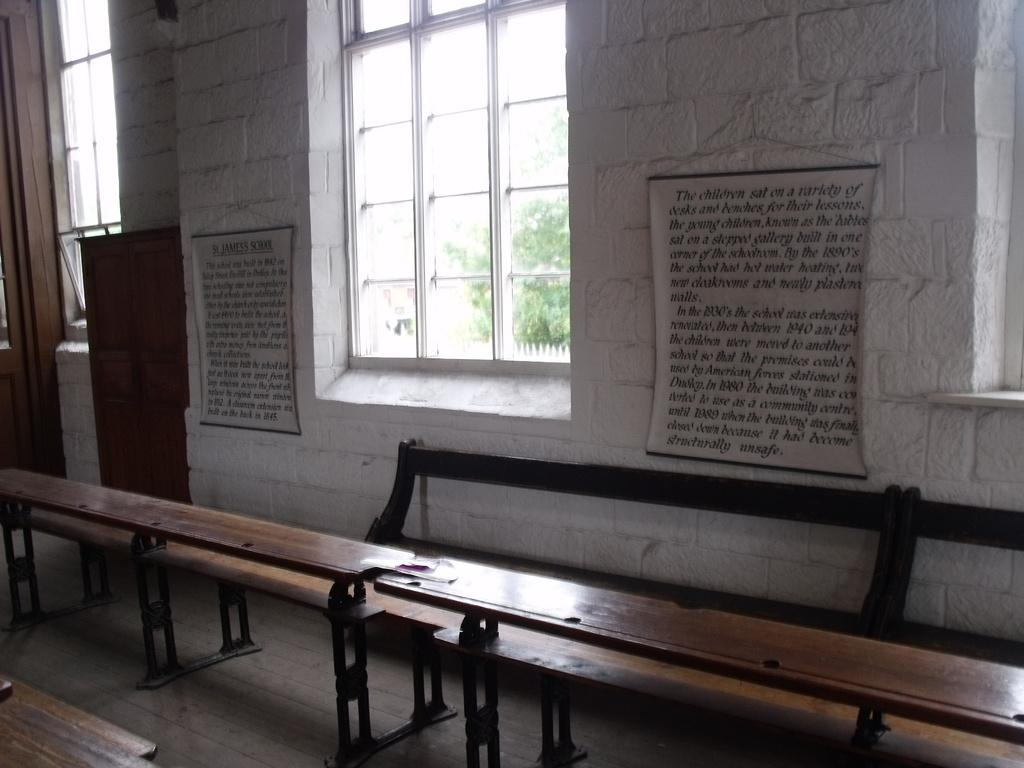What type of furniture is present in the image? There are benches and tables in the image. What can be seen in the background of the image? There is a wall, windows, boards, and trees in the background of the image. Can you describe the setting where the image might have been taken? The image may have been taken in a hall, as there are benches and tables arranged in a large space. What type of car is parked on the floor in the image? There is no car present in the image; it features benches, tables, and elements in the background. 